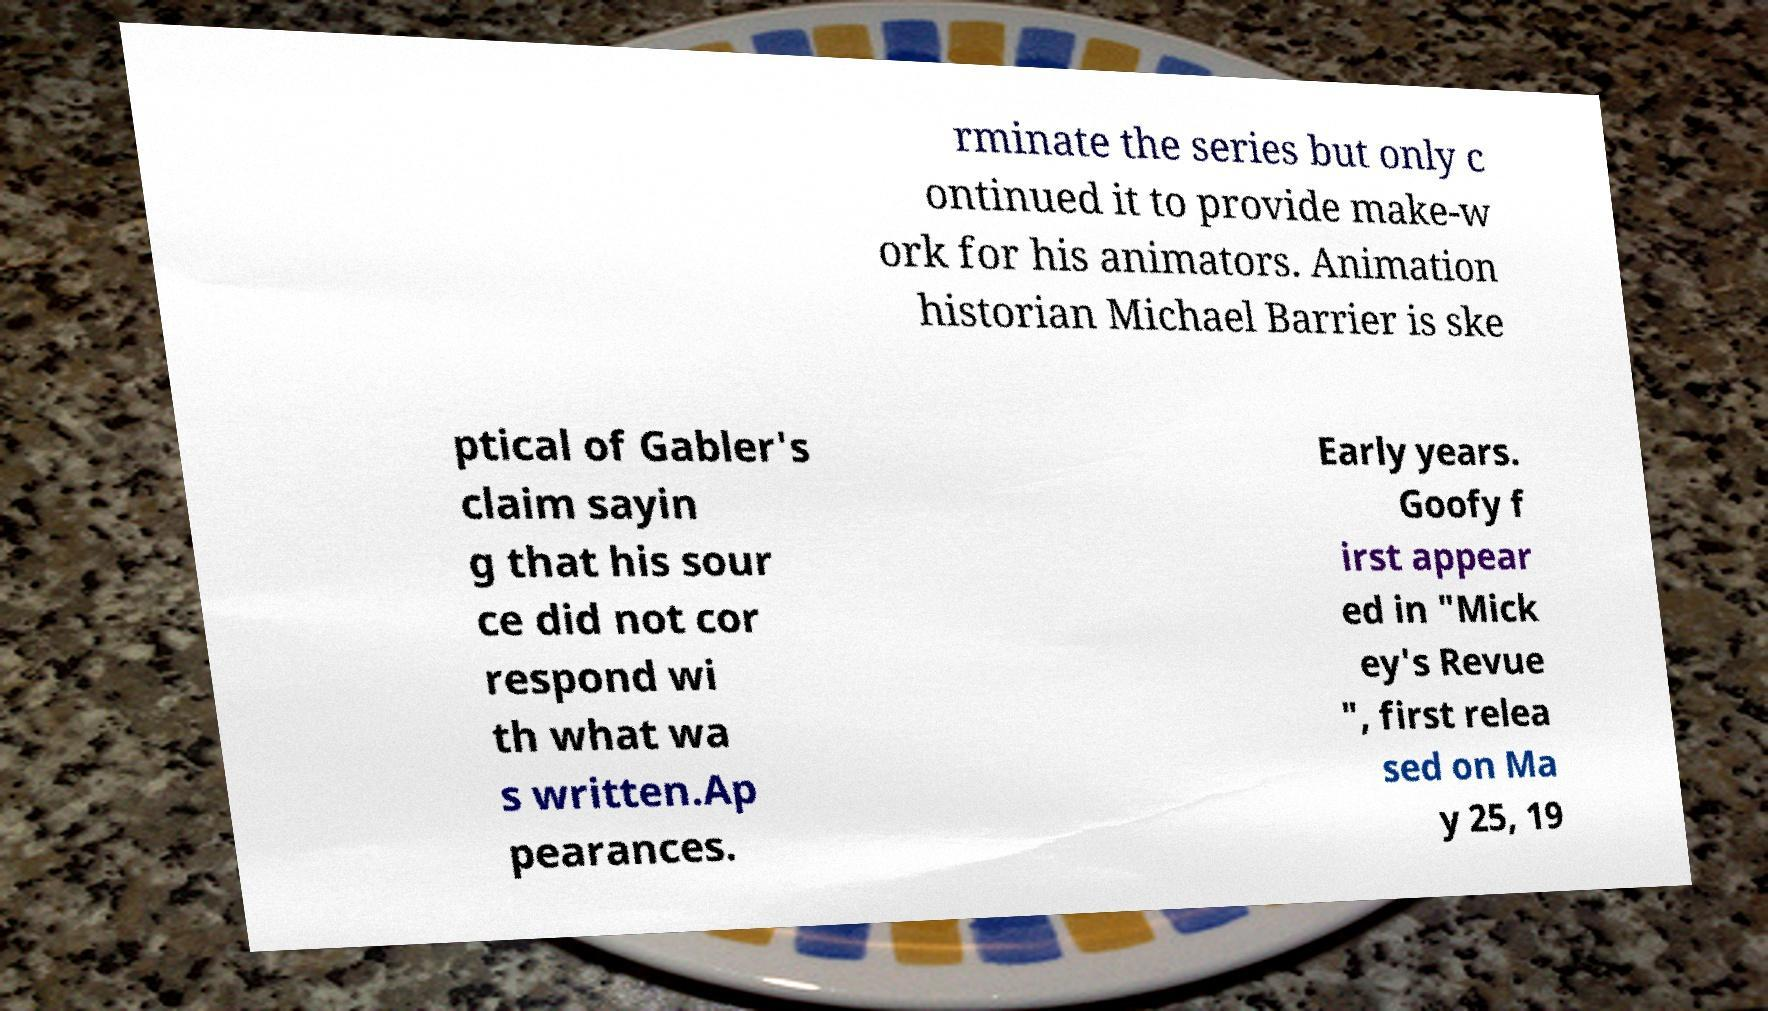Can you read and provide the text displayed in the image?This photo seems to have some interesting text. Can you extract and type it out for me? rminate the series but only c ontinued it to provide make-w ork for his animators. Animation historian Michael Barrier is ske ptical of Gabler's claim sayin g that his sour ce did not cor respond wi th what wa s written.Ap pearances. Early years. Goofy f irst appear ed in "Mick ey's Revue ", first relea sed on Ma y 25, 19 